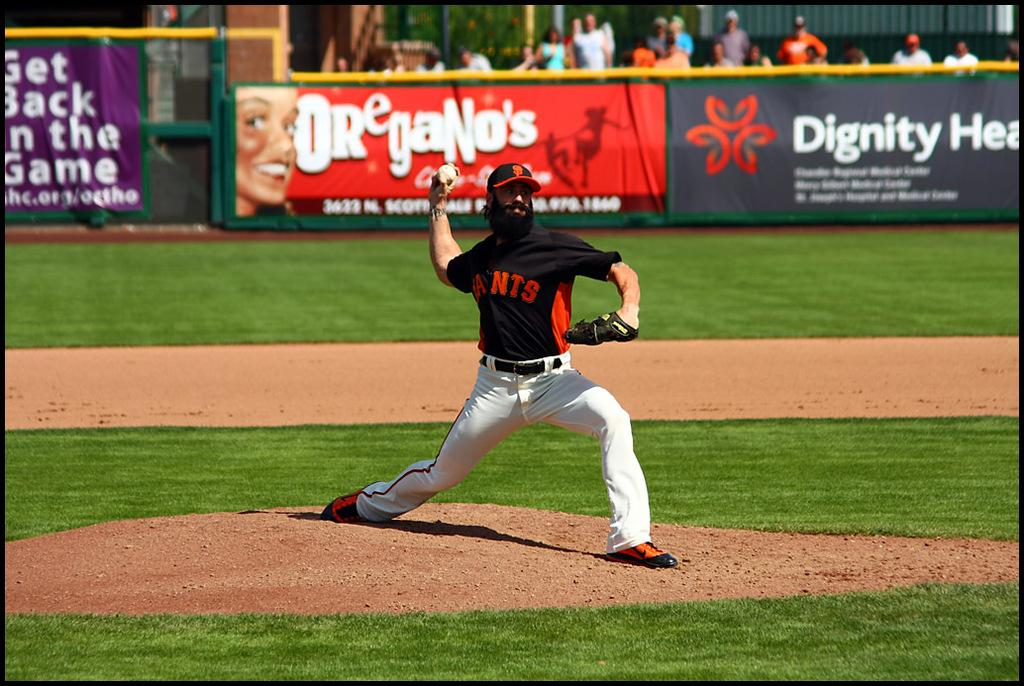<image>
Relay a brief, clear account of the picture shown. The pitcher for the San Francisco Giants is throwing a pitch during a game. 